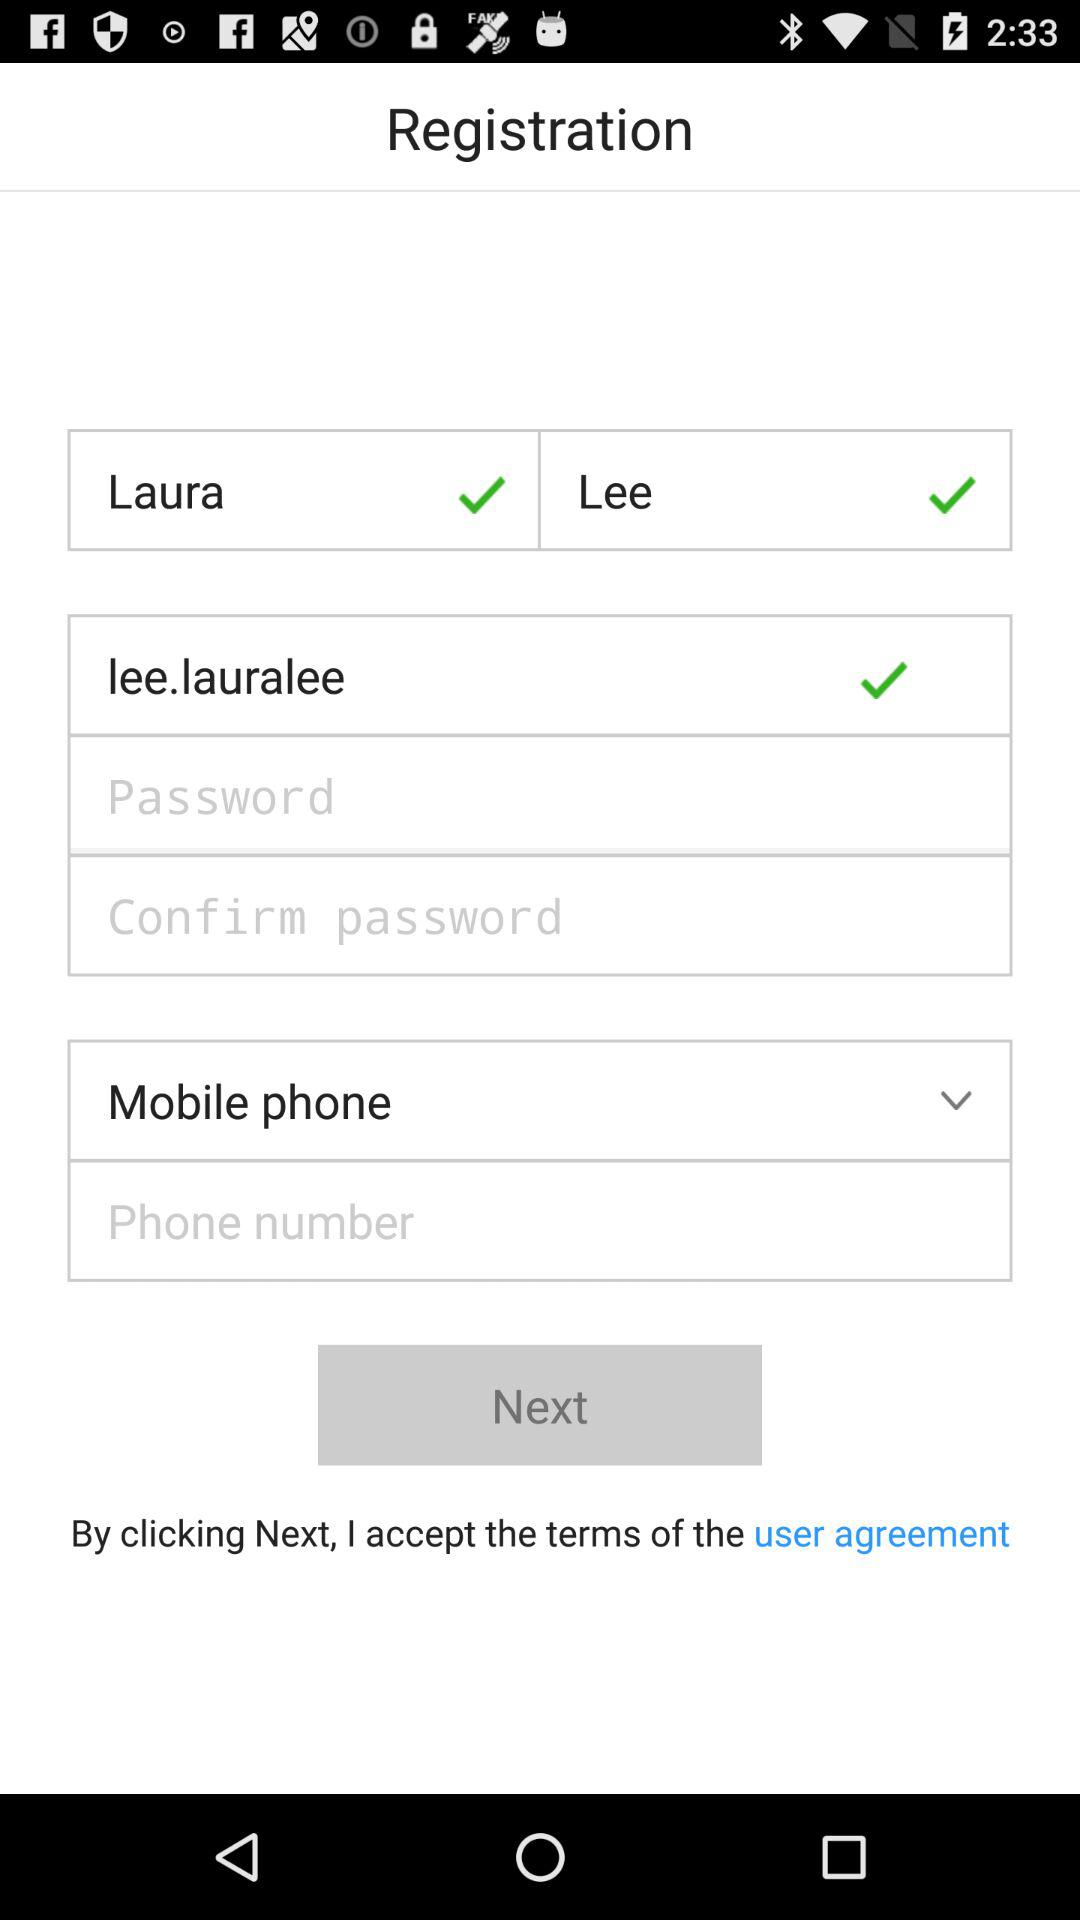How many check marks are there in the registration form?
Answer the question using a single word or phrase. 3 